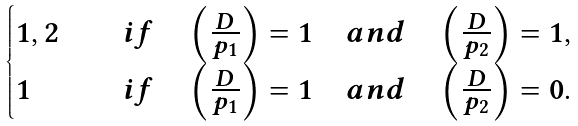<formula> <loc_0><loc_0><loc_500><loc_500>\begin{cases} 1 , 2 \quad & i f \quad \left ( \frac { D } { p _ { 1 } } \right ) = 1 \quad a n d \quad \left ( \frac { D } { p _ { 2 } } \right ) = 1 , \\ 1 \quad & i f \quad \left ( \frac { D } { p _ { 1 } } \right ) = 1 \quad a n d \quad \left ( \frac { D } { p _ { 2 } } \right ) = 0 . \end{cases}</formula> 